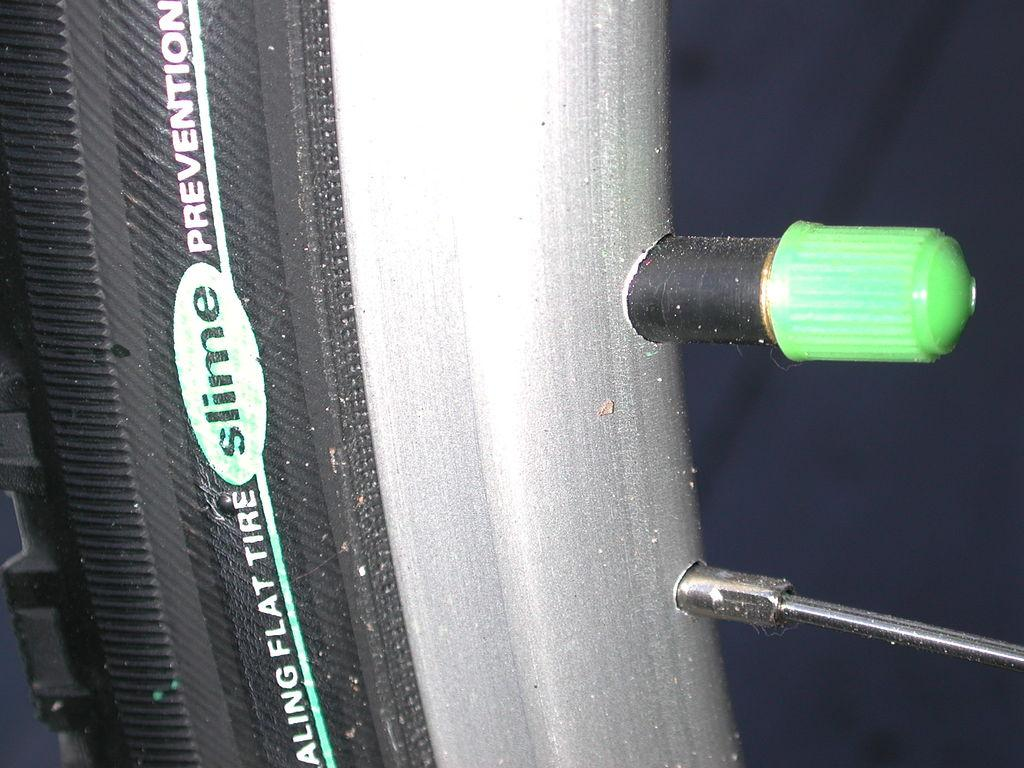<image>
Describe the image concisely. A bicycle tire made by the company Slime. 